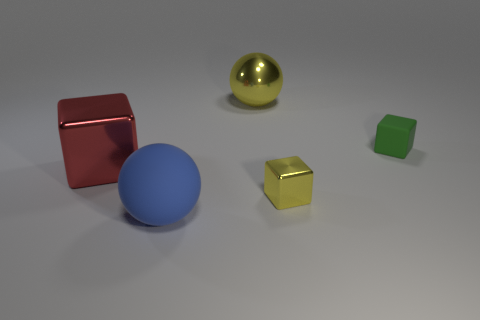There is a big shiny object that is behind the red metal object; does it have the same shape as the blue object that is right of the large red object?
Your response must be concise. Yes. What material is the blue ball?
Give a very brief answer. Rubber. There is another metallic object that is the same color as the small shiny object; what shape is it?
Give a very brief answer. Sphere. What number of yellow cubes are the same size as the green block?
Give a very brief answer. 1. What number of objects are large shiny objects behind the red metallic thing or big shiny things behind the red thing?
Offer a very short reply. 1. Does the large ball that is behind the blue object have the same material as the sphere that is in front of the yellow ball?
Give a very brief answer. No. What is the shape of the rubber object behind the object that is on the left side of the large matte thing?
Provide a succinct answer. Cube. Is there anything else that has the same color as the small metallic block?
Your answer should be compact. Yes. There is a matte thing that is on the right side of the large metal thing behind the red metal cube; is there a ball that is to the right of it?
Provide a short and direct response. No. Do the tiny shiny block behind the blue thing and the big sphere behind the large blue thing have the same color?
Provide a succinct answer. Yes. 